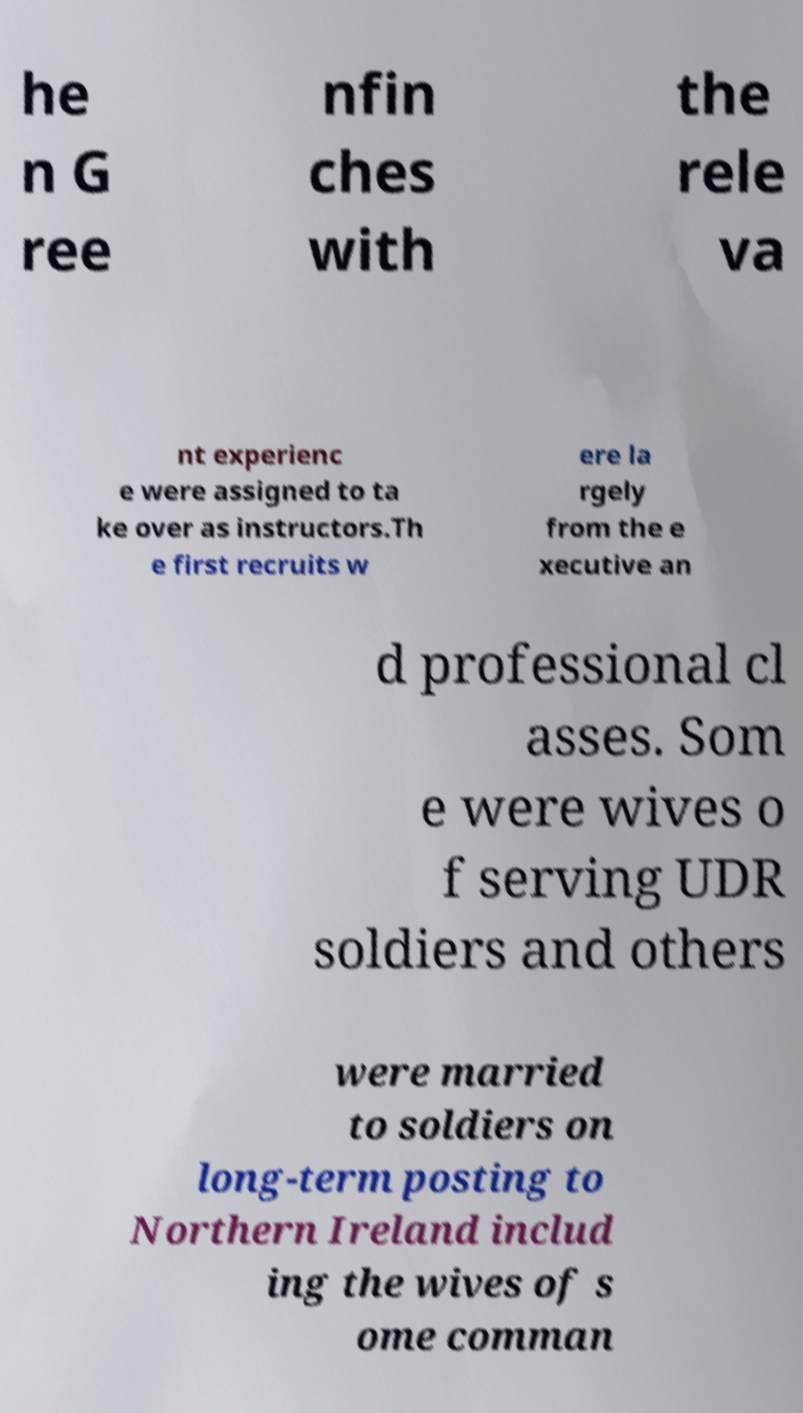Can you accurately transcribe the text from the provided image for me? he n G ree nfin ches with the rele va nt experienc e were assigned to ta ke over as instructors.Th e first recruits w ere la rgely from the e xecutive an d professional cl asses. Som e were wives o f serving UDR soldiers and others were married to soldiers on long-term posting to Northern Ireland includ ing the wives of s ome comman 